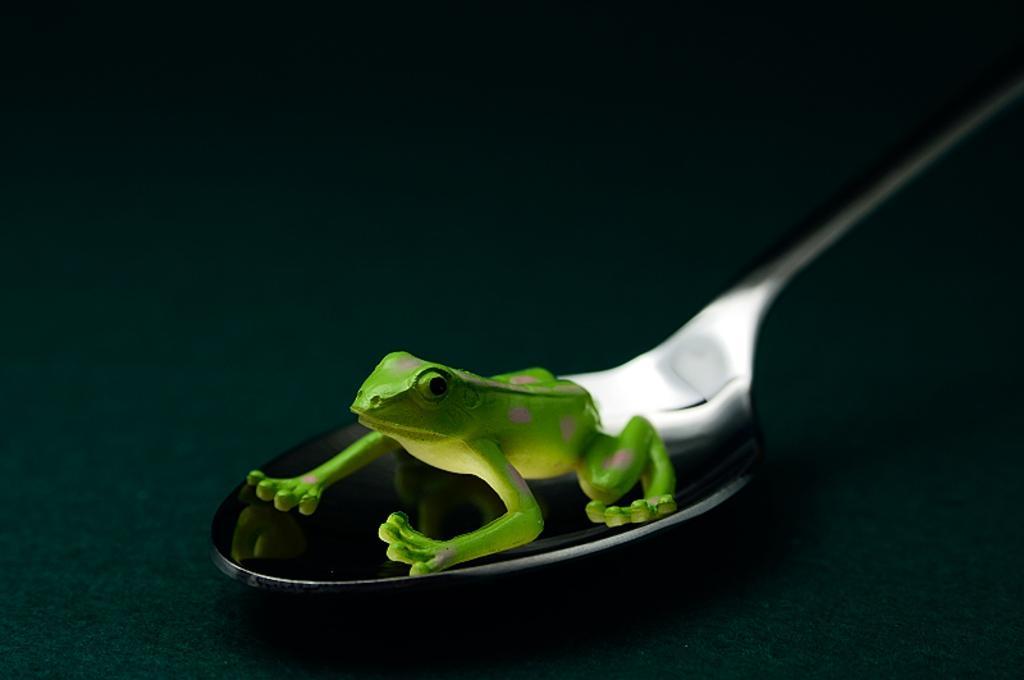Describe this image in one or two sentences. In this picture we can see a toy frog on the spoon and the spoon is on an object. Behind the spoon, there is the dark background. 